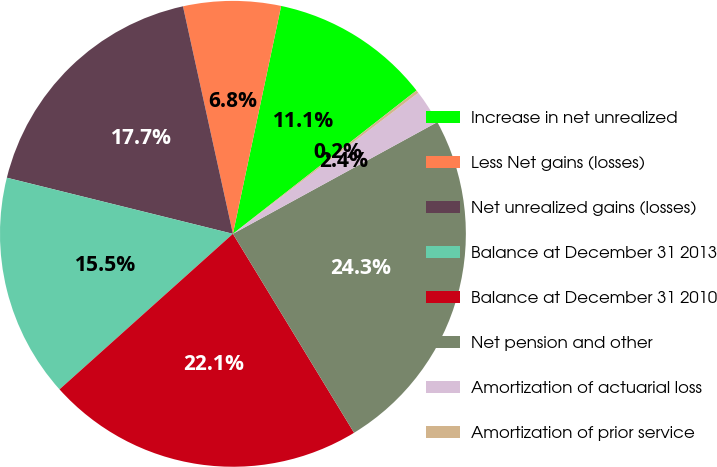Convert chart. <chart><loc_0><loc_0><loc_500><loc_500><pie_chart><fcel>Increase in net unrealized<fcel>Less Net gains (losses)<fcel>Net unrealized gains (losses)<fcel>Balance at December 31 2013<fcel>Balance at December 31 2010<fcel>Net pension and other<fcel>Amortization of actuarial loss<fcel>Amortization of prior service<nl><fcel>11.13%<fcel>6.76%<fcel>17.69%<fcel>15.51%<fcel>22.07%<fcel>24.26%<fcel>2.39%<fcel>0.2%<nl></chart> 